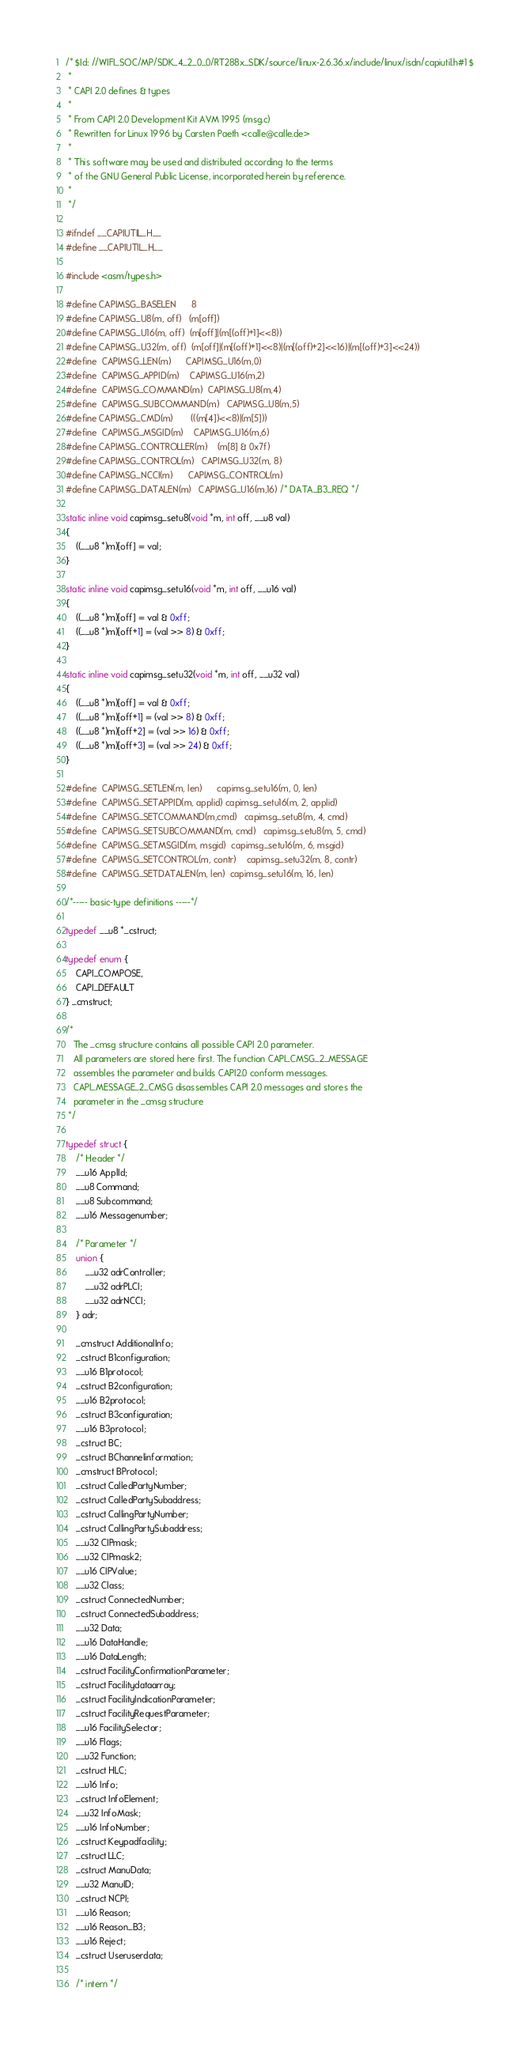Convert code to text. <code><loc_0><loc_0><loc_500><loc_500><_C_>/* $Id: //WIFI_SOC/MP/SDK_4_2_0_0/RT288x_SDK/source/linux-2.6.36.x/include/linux/isdn/capiutil.h#1 $
 *
 * CAPI 2.0 defines & types
 *
 * From CAPI 2.0 Development Kit AVM 1995 (msg.c)
 * Rewritten for Linux 1996 by Carsten Paeth <calle@calle.de>
 *
 * This software may be used and distributed according to the terms
 * of the GNU General Public License, incorporated herein by reference.
 *
 */

#ifndef __CAPIUTIL_H__
#define __CAPIUTIL_H__

#include <asm/types.h>

#define CAPIMSG_BASELEN		8
#define CAPIMSG_U8(m, off)	(m[off])
#define CAPIMSG_U16(m, off)	(m[off]|(m[(off)+1]<<8))
#define CAPIMSG_U32(m, off)	(m[off]|(m[(off)+1]<<8)|(m[(off)+2]<<16)|(m[(off)+3]<<24))
#define	CAPIMSG_LEN(m)		CAPIMSG_U16(m,0)
#define	CAPIMSG_APPID(m)	CAPIMSG_U16(m,2)
#define	CAPIMSG_COMMAND(m)	CAPIMSG_U8(m,4)
#define	CAPIMSG_SUBCOMMAND(m)	CAPIMSG_U8(m,5)
#define CAPIMSG_CMD(m)		(((m[4])<<8)|(m[5]))
#define	CAPIMSG_MSGID(m)	CAPIMSG_U16(m,6)
#define CAPIMSG_CONTROLLER(m)	(m[8] & 0x7f)
#define CAPIMSG_CONTROL(m)	CAPIMSG_U32(m, 8)
#define CAPIMSG_NCCI(m)		CAPIMSG_CONTROL(m)
#define CAPIMSG_DATALEN(m)	CAPIMSG_U16(m,16) /* DATA_B3_REQ */

static inline void capimsg_setu8(void *m, int off, __u8 val)
{
	((__u8 *)m)[off] = val;
}

static inline void capimsg_setu16(void *m, int off, __u16 val)
{
	((__u8 *)m)[off] = val & 0xff;
	((__u8 *)m)[off+1] = (val >> 8) & 0xff;
}

static inline void capimsg_setu32(void *m, int off, __u32 val)
{
	((__u8 *)m)[off] = val & 0xff;
	((__u8 *)m)[off+1] = (val >> 8) & 0xff;
	((__u8 *)m)[off+2] = (val >> 16) & 0xff;
	((__u8 *)m)[off+3] = (val >> 24) & 0xff;
}

#define	CAPIMSG_SETLEN(m, len)		capimsg_setu16(m, 0, len)
#define	CAPIMSG_SETAPPID(m, applid)	capimsg_setu16(m, 2, applid)
#define	CAPIMSG_SETCOMMAND(m,cmd)	capimsg_setu8(m, 4, cmd)
#define	CAPIMSG_SETSUBCOMMAND(m, cmd)	capimsg_setu8(m, 5, cmd)
#define	CAPIMSG_SETMSGID(m, msgid)	capimsg_setu16(m, 6, msgid)
#define	CAPIMSG_SETCONTROL(m, contr)	capimsg_setu32(m, 8, contr)
#define	CAPIMSG_SETDATALEN(m, len)	capimsg_setu16(m, 16, len)

/*----- basic-type definitions -----*/

typedef __u8 *_cstruct;

typedef enum {
	CAPI_COMPOSE,
	CAPI_DEFAULT
} _cmstruct;

/*
   The _cmsg structure contains all possible CAPI 2.0 parameter.
   All parameters are stored here first. The function CAPI_CMSG_2_MESSAGE
   assembles the parameter and builds CAPI2.0 conform messages.
   CAPI_MESSAGE_2_CMSG disassembles CAPI 2.0 messages and stores the
   parameter in the _cmsg structure
 */

typedef struct {
	/* Header */
	__u16 ApplId;
	__u8 Command;
	__u8 Subcommand;
	__u16 Messagenumber;

	/* Parameter */
	union {
		__u32 adrController;
		__u32 adrPLCI;
		__u32 adrNCCI;
	} adr;

	_cmstruct AdditionalInfo;
	_cstruct B1configuration;
	__u16 B1protocol;
	_cstruct B2configuration;
	__u16 B2protocol;
	_cstruct B3configuration;
	__u16 B3protocol;
	_cstruct BC;
	_cstruct BChannelinformation;
	_cmstruct BProtocol;
	_cstruct CalledPartyNumber;
	_cstruct CalledPartySubaddress;
	_cstruct CallingPartyNumber;
	_cstruct CallingPartySubaddress;
	__u32 CIPmask;
	__u32 CIPmask2;
	__u16 CIPValue;
	__u32 Class;
	_cstruct ConnectedNumber;
	_cstruct ConnectedSubaddress;
	__u32 Data;
	__u16 DataHandle;
	__u16 DataLength;
	_cstruct FacilityConfirmationParameter;
	_cstruct Facilitydataarray;
	_cstruct FacilityIndicationParameter;
	_cstruct FacilityRequestParameter;
	__u16 FacilitySelector;
	__u16 Flags;
	__u32 Function;
	_cstruct HLC;
	__u16 Info;
	_cstruct InfoElement;
	__u32 InfoMask;
	__u16 InfoNumber;
	_cstruct Keypadfacility;
	_cstruct LLC;
	_cstruct ManuData;
	__u32 ManuID;
	_cstruct NCPI;
	__u16 Reason;
	__u16 Reason_B3;
	__u16 Reject;
	_cstruct Useruserdata;

	/* intern */</code> 